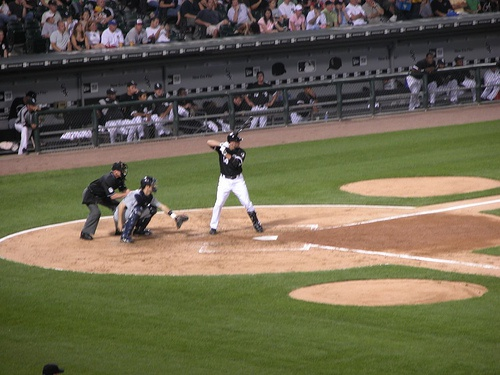Describe the objects in this image and their specific colors. I can see people in black, gray, and darkgray tones, people in black, lavender, gray, and darkgray tones, people in black, gray, tan, and darkgray tones, people in black, gray, and darkgreen tones, and people in black and gray tones in this image. 